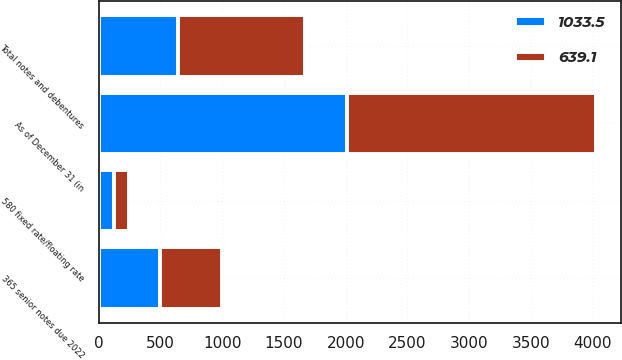Convert chart to OTSL. <chart><loc_0><loc_0><loc_500><loc_500><stacked_bar_chart><ecel><fcel>As of December 31 (in<fcel>365 senior notes due 2022<fcel>580 fixed rate/floating rate<fcel>Total notes and debentures<nl><fcel>639.1<fcel>2014<fcel>498.6<fcel>122.5<fcel>1033.5<nl><fcel>1033.5<fcel>2013<fcel>498.5<fcel>121.2<fcel>639.1<nl></chart> 